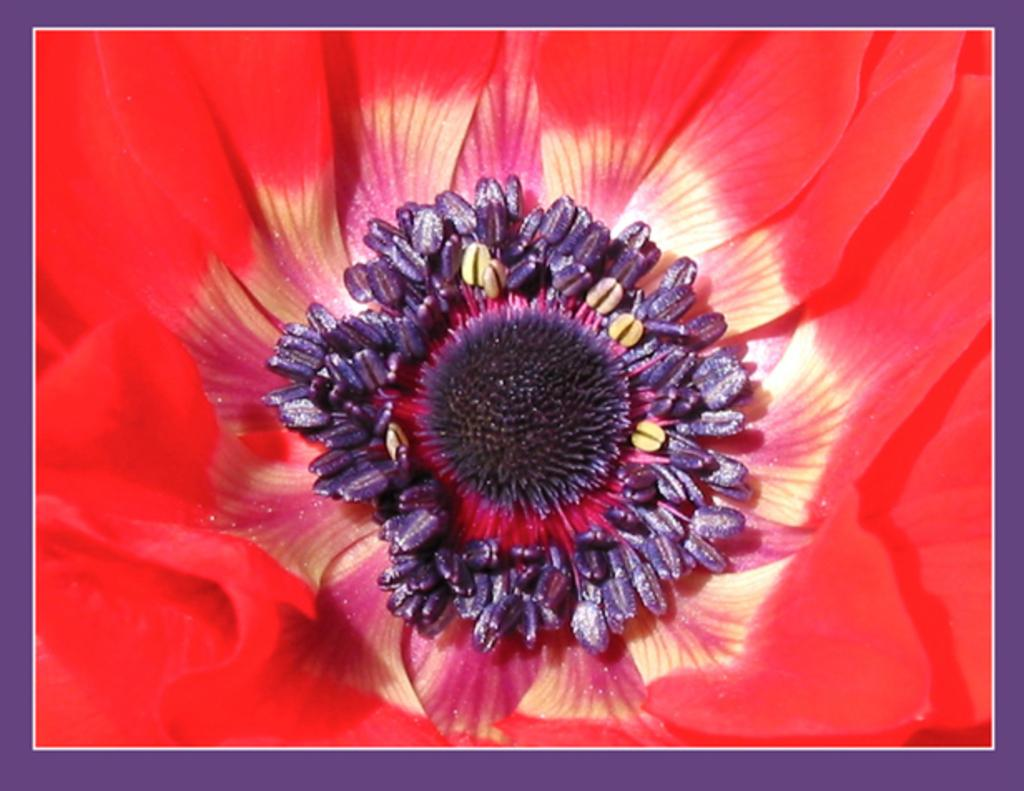What is the main subject of the image? There is a flower in the image. How many cakes are displayed on the cushion in the image? There are no cakes or cushions present in the image; it features a flower. 